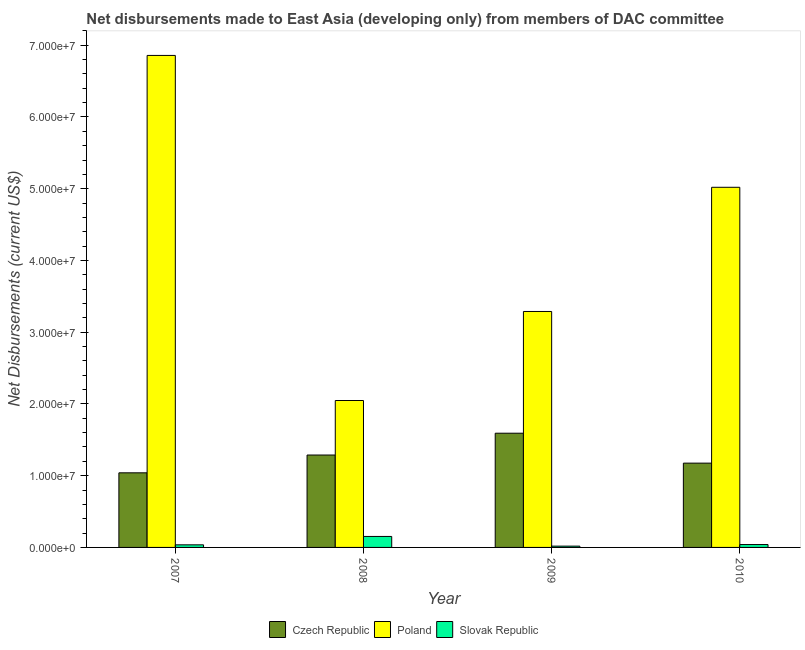How many groups of bars are there?
Provide a short and direct response. 4. Are the number of bars per tick equal to the number of legend labels?
Your answer should be compact. Yes. How many bars are there on the 1st tick from the right?
Give a very brief answer. 3. What is the label of the 1st group of bars from the left?
Give a very brief answer. 2007. What is the net disbursements made by czech republic in 2008?
Ensure brevity in your answer.  1.29e+07. Across all years, what is the maximum net disbursements made by poland?
Keep it short and to the point. 6.86e+07. Across all years, what is the minimum net disbursements made by poland?
Keep it short and to the point. 2.05e+07. In which year was the net disbursements made by czech republic maximum?
Make the answer very short. 2009. What is the total net disbursements made by slovak republic in the graph?
Provide a succinct answer. 2.47e+06. What is the difference between the net disbursements made by poland in 2007 and that in 2010?
Ensure brevity in your answer.  1.84e+07. What is the difference between the net disbursements made by slovak republic in 2008 and the net disbursements made by poland in 2009?
Make the answer very short. 1.35e+06. What is the average net disbursements made by czech republic per year?
Your answer should be compact. 1.27e+07. What is the ratio of the net disbursements made by slovak republic in 2008 to that in 2010?
Your answer should be very brief. 3.83. Is the net disbursements made by poland in 2007 less than that in 2010?
Your answer should be very brief. No. What is the difference between the highest and the second highest net disbursements made by czech republic?
Offer a terse response. 3.04e+06. What is the difference between the highest and the lowest net disbursements made by poland?
Make the answer very short. 4.81e+07. In how many years, is the net disbursements made by czech republic greater than the average net disbursements made by czech republic taken over all years?
Give a very brief answer. 2. Is the sum of the net disbursements made by slovak republic in 2008 and 2010 greater than the maximum net disbursements made by czech republic across all years?
Provide a succinct answer. Yes. What does the 1st bar from the left in 2010 represents?
Make the answer very short. Czech Republic. What does the 3rd bar from the right in 2010 represents?
Provide a succinct answer. Czech Republic. Are all the bars in the graph horizontal?
Offer a terse response. No. What is the difference between two consecutive major ticks on the Y-axis?
Offer a terse response. 1.00e+07. Are the values on the major ticks of Y-axis written in scientific E-notation?
Your answer should be compact. Yes. Does the graph contain any zero values?
Ensure brevity in your answer.  No. Does the graph contain grids?
Give a very brief answer. No. How many legend labels are there?
Give a very brief answer. 3. How are the legend labels stacked?
Your response must be concise. Horizontal. What is the title of the graph?
Make the answer very short. Net disbursements made to East Asia (developing only) from members of DAC committee. What is the label or title of the X-axis?
Offer a very short reply. Year. What is the label or title of the Y-axis?
Offer a terse response. Net Disbursements (current US$). What is the Net Disbursements (current US$) in Czech Republic in 2007?
Ensure brevity in your answer.  1.04e+07. What is the Net Disbursements (current US$) in Poland in 2007?
Offer a terse response. 6.86e+07. What is the Net Disbursements (current US$) of Czech Republic in 2008?
Give a very brief answer. 1.29e+07. What is the Net Disbursements (current US$) of Poland in 2008?
Your answer should be compact. 2.05e+07. What is the Net Disbursements (current US$) in Slovak Republic in 2008?
Offer a very short reply. 1.53e+06. What is the Net Disbursements (current US$) of Czech Republic in 2009?
Keep it short and to the point. 1.59e+07. What is the Net Disbursements (current US$) of Poland in 2009?
Your response must be concise. 3.29e+07. What is the Net Disbursements (current US$) in Czech Republic in 2010?
Your answer should be compact. 1.18e+07. What is the Net Disbursements (current US$) of Poland in 2010?
Ensure brevity in your answer.  5.02e+07. Across all years, what is the maximum Net Disbursements (current US$) of Czech Republic?
Provide a succinct answer. 1.59e+07. Across all years, what is the maximum Net Disbursements (current US$) in Poland?
Make the answer very short. 6.86e+07. Across all years, what is the maximum Net Disbursements (current US$) of Slovak Republic?
Your answer should be compact. 1.53e+06. Across all years, what is the minimum Net Disbursements (current US$) of Czech Republic?
Keep it short and to the point. 1.04e+07. Across all years, what is the minimum Net Disbursements (current US$) of Poland?
Ensure brevity in your answer.  2.05e+07. Across all years, what is the minimum Net Disbursements (current US$) in Slovak Republic?
Give a very brief answer. 1.80e+05. What is the total Net Disbursements (current US$) in Czech Republic in the graph?
Give a very brief answer. 5.10e+07. What is the total Net Disbursements (current US$) in Poland in the graph?
Provide a succinct answer. 1.72e+08. What is the total Net Disbursements (current US$) of Slovak Republic in the graph?
Give a very brief answer. 2.47e+06. What is the difference between the Net Disbursements (current US$) in Czech Republic in 2007 and that in 2008?
Provide a short and direct response. -2.48e+06. What is the difference between the Net Disbursements (current US$) of Poland in 2007 and that in 2008?
Offer a terse response. 4.81e+07. What is the difference between the Net Disbursements (current US$) of Slovak Republic in 2007 and that in 2008?
Provide a succinct answer. -1.17e+06. What is the difference between the Net Disbursements (current US$) in Czech Republic in 2007 and that in 2009?
Offer a terse response. -5.52e+06. What is the difference between the Net Disbursements (current US$) in Poland in 2007 and that in 2009?
Your answer should be very brief. 3.57e+07. What is the difference between the Net Disbursements (current US$) of Slovak Republic in 2007 and that in 2009?
Provide a succinct answer. 1.80e+05. What is the difference between the Net Disbursements (current US$) of Czech Republic in 2007 and that in 2010?
Ensure brevity in your answer.  -1.35e+06. What is the difference between the Net Disbursements (current US$) of Poland in 2007 and that in 2010?
Offer a terse response. 1.84e+07. What is the difference between the Net Disbursements (current US$) of Slovak Republic in 2007 and that in 2010?
Make the answer very short. -4.00e+04. What is the difference between the Net Disbursements (current US$) in Czech Republic in 2008 and that in 2009?
Keep it short and to the point. -3.04e+06. What is the difference between the Net Disbursements (current US$) in Poland in 2008 and that in 2009?
Give a very brief answer. -1.24e+07. What is the difference between the Net Disbursements (current US$) in Slovak Republic in 2008 and that in 2009?
Offer a very short reply. 1.35e+06. What is the difference between the Net Disbursements (current US$) of Czech Republic in 2008 and that in 2010?
Offer a terse response. 1.13e+06. What is the difference between the Net Disbursements (current US$) in Poland in 2008 and that in 2010?
Give a very brief answer. -2.97e+07. What is the difference between the Net Disbursements (current US$) of Slovak Republic in 2008 and that in 2010?
Provide a short and direct response. 1.13e+06. What is the difference between the Net Disbursements (current US$) of Czech Republic in 2009 and that in 2010?
Offer a very short reply. 4.17e+06. What is the difference between the Net Disbursements (current US$) of Poland in 2009 and that in 2010?
Keep it short and to the point. -1.73e+07. What is the difference between the Net Disbursements (current US$) in Slovak Republic in 2009 and that in 2010?
Provide a succinct answer. -2.20e+05. What is the difference between the Net Disbursements (current US$) of Czech Republic in 2007 and the Net Disbursements (current US$) of Poland in 2008?
Keep it short and to the point. -1.01e+07. What is the difference between the Net Disbursements (current US$) of Czech Republic in 2007 and the Net Disbursements (current US$) of Slovak Republic in 2008?
Provide a succinct answer. 8.87e+06. What is the difference between the Net Disbursements (current US$) of Poland in 2007 and the Net Disbursements (current US$) of Slovak Republic in 2008?
Your answer should be compact. 6.70e+07. What is the difference between the Net Disbursements (current US$) of Czech Republic in 2007 and the Net Disbursements (current US$) of Poland in 2009?
Your answer should be very brief. -2.25e+07. What is the difference between the Net Disbursements (current US$) of Czech Republic in 2007 and the Net Disbursements (current US$) of Slovak Republic in 2009?
Give a very brief answer. 1.02e+07. What is the difference between the Net Disbursements (current US$) in Poland in 2007 and the Net Disbursements (current US$) in Slovak Republic in 2009?
Your response must be concise. 6.84e+07. What is the difference between the Net Disbursements (current US$) of Czech Republic in 2007 and the Net Disbursements (current US$) of Poland in 2010?
Your response must be concise. -3.98e+07. What is the difference between the Net Disbursements (current US$) of Czech Republic in 2007 and the Net Disbursements (current US$) of Slovak Republic in 2010?
Ensure brevity in your answer.  1.00e+07. What is the difference between the Net Disbursements (current US$) in Poland in 2007 and the Net Disbursements (current US$) in Slovak Republic in 2010?
Offer a very short reply. 6.82e+07. What is the difference between the Net Disbursements (current US$) of Czech Republic in 2008 and the Net Disbursements (current US$) of Poland in 2009?
Offer a very short reply. -2.00e+07. What is the difference between the Net Disbursements (current US$) in Czech Republic in 2008 and the Net Disbursements (current US$) in Slovak Republic in 2009?
Your response must be concise. 1.27e+07. What is the difference between the Net Disbursements (current US$) in Poland in 2008 and the Net Disbursements (current US$) in Slovak Republic in 2009?
Offer a terse response. 2.03e+07. What is the difference between the Net Disbursements (current US$) of Czech Republic in 2008 and the Net Disbursements (current US$) of Poland in 2010?
Provide a succinct answer. -3.73e+07. What is the difference between the Net Disbursements (current US$) in Czech Republic in 2008 and the Net Disbursements (current US$) in Slovak Republic in 2010?
Your answer should be compact. 1.25e+07. What is the difference between the Net Disbursements (current US$) in Poland in 2008 and the Net Disbursements (current US$) in Slovak Republic in 2010?
Offer a very short reply. 2.01e+07. What is the difference between the Net Disbursements (current US$) of Czech Republic in 2009 and the Net Disbursements (current US$) of Poland in 2010?
Provide a succinct answer. -3.43e+07. What is the difference between the Net Disbursements (current US$) of Czech Republic in 2009 and the Net Disbursements (current US$) of Slovak Republic in 2010?
Give a very brief answer. 1.55e+07. What is the difference between the Net Disbursements (current US$) of Poland in 2009 and the Net Disbursements (current US$) of Slovak Republic in 2010?
Offer a terse response. 3.25e+07. What is the average Net Disbursements (current US$) in Czech Republic per year?
Your answer should be compact. 1.27e+07. What is the average Net Disbursements (current US$) of Poland per year?
Provide a succinct answer. 4.30e+07. What is the average Net Disbursements (current US$) of Slovak Republic per year?
Give a very brief answer. 6.18e+05. In the year 2007, what is the difference between the Net Disbursements (current US$) of Czech Republic and Net Disbursements (current US$) of Poland?
Your response must be concise. -5.82e+07. In the year 2007, what is the difference between the Net Disbursements (current US$) of Czech Republic and Net Disbursements (current US$) of Slovak Republic?
Your answer should be compact. 1.00e+07. In the year 2007, what is the difference between the Net Disbursements (current US$) in Poland and Net Disbursements (current US$) in Slovak Republic?
Offer a terse response. 6.82e+07. In the year 2008, what is the difference between the Net Disbursements (current US$) in Czech Republic and Net Disbursements (current US$) in Poland?
Offer a very short reply. -7.60e+06. In the year 2008, what is the difference between the Net Disbursements (current US$) in Czech Republic and Net Disbursements (current US$) in Slovak Republic?
Provide a succinct answer. 1.14e+07. In the year 2008, what is the difference between the Net Disbursements (current US$) in Poland and Net Disbursements (current US$) in Slovak Republic?
Keep it short and to the point. 1.90e+07. In the year 2009, what is the difference between the Net Disbursements (current US$) of Czech Republic and Net Disbursements (current US$) of Poland?
Offer a terse response. -1.70e+07. In the year 2009, what is the difference between the Net Disbursements (current US$) of Czech Republic and Net Disbursements (current US$) of Slovak Republic?
Your response must be concise. 1.57e+07. In the year 2009, what is the difference between the Net Disbursements (current US$) of Poland and Net Disbursements (current US$) of Slovak Republic?
Provide a short and direct response. 3.27e+07. In the year 2010, what is the difference between the Net Disbursements (current US$) of Czech Republic and Net Disbursements (current US$) of Poland?
Make the answer very short. -3.84e+07. In the year 2010, what is the difference between the Net Disbursements (current US$) in Czech Republic and Net Disbursements (current US$) in Slovak Republic?
Offer a terse response. 1.14e+07. In the year 2010, what is the difference between the Net Disbursements (current US$) of Poland and Net Disbursements (current US$) of Slovak Republic?
Offer a terse response. 4.98e+07. What is the ratio of the Net Disbursements (current US$) in Czech Republic in 2007 to that in 2008?
Provide a short and direct response. 0.81. What is the ratio of the Net Disbursements (current US$) in Poland in 2007 to that in 2008?
Keep it short and to the point. 3.35. What is the ratio of the Net Disbursements (current US$) of Slovak Republic in 2007 to that in 2008?
Provide a short and direct response. 0.24. What is the ratio of the Net Disbursements (current US$) of Czech Republic in 2007 to that in 2009?
Offer a terse response. 0.65. What is the ratio of the Net Disbursements (current US$) in Poland in 2007 to that in 2009?
Your answer should be very brief. 2.09. What is the ratio of the Net Disbursements (current US$) of Slovak Republic in 2007 to that in 2009?
Your response must be concise. 2. What is the ratio of the Net Disbursements (current US$) of Czech Republic in 2007 to that in 2010?
Keep it short and to the point. 0.89. What is the ratio of the Net Disbursements (current US$) in Poland in 2007 to that in 2010?
Your answer should be compact. 1.37. What is the ratio of the Net Disbursements (current US$) of Slovak Republic in 2007 to that in 2010?
Provide a succinct answer. 0.9. What is the ratio of the Net Disbursements (current US$) of Czech Republic in 2008 to that in 2009?
Ensure brevity in your answer.  0.81. What is the ratio of the Net Disbursements (current US$) of Poland in 2008 to that in 2009?
Provide a succinct answer. 0.62. What is the ratio of the Net Disbursements (current US$) of Czech Republic in 2008 to that in 2010?
Offer a terse response. 1.1. What is the ratio of the Net Disbursements (current US$) of Poland in 2008 to that in 2010?
Your response must be concise. 0.41. What is the ratio of the Net Disbursements (current US$) of Slovak Republic in 2008 to that in 2010?
Offer a very short reply. 3.83. What is the ratio of the Net Disbursements (current US$) of Czech Republic in 2009 to that in 2010?
Offer a very short reply. 1.35. What is the ratio of the Net Disbursements (current US$) in Poland in 2009 to that in 2010?
Ensure brevity in your answer.  0.66. What is the ratio of the Net Disbursements (current US$) in Slovak Republic in 2009 to that in 2010?
Give a very brief answer. 0.45. What is the difference between the highest and the second highest Net Disbursements (current US$) of Czech Republic?
Keep it short and to the point. 3.04e+06. What is the difference between the highest and the second highest Net Disbursements (current US$) in Poland?
Provide a short and direct response. 1.84e+07. What is the difference between the highest and the second highest Net Disbursements (current US$) in Slovak Republic?
Offer a very short reply. 1.13e+06. What is the difference between the highest and the lowest Net Disbursements (current US$) in Czech Republic?
Provide a succinct answer. 5.52e+06. What is the difference between the highest and the lowest Net Disbursements (current US$) of Poland?
Your answer should be very brief. 4.81e+07. What is the difference between the highest and the lowest Net Disbursements (current US$) of Slovak Republic?
Make the answer very short. 1.35e+06. 